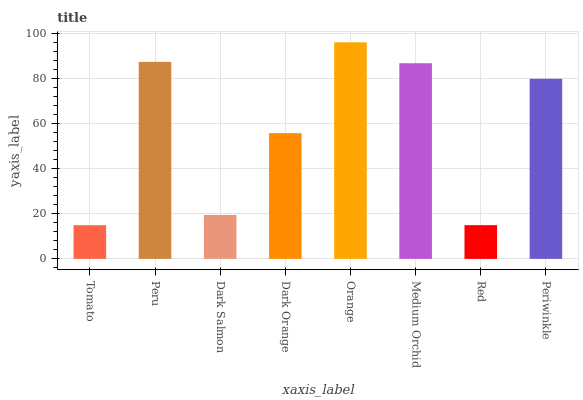Is Tomato the minimum?
Answer yes or no. Yes. Is Orange the maximum?
Answer yes or no. Yes. Is Peru the minimum?
Answer yes or no. No. Is Peru the maximum?
Answer yes or no. No. Is Peru greater than Tomato?
Answer yes or no. Yes. Is Tomato less than Peru?
Answer yes or no. Yes. Is Tomato greater than Peru?
Answer yes or no. No. Is Peru less than Tomato?
Answer yes or no. No. Is Periwinkle the high median?
Answer yes or no. Yes. Is Dark Orange the low median?
Answer yes or no. Yes. Is Peru the high median?
Answer yes or no. No. Is Medium Orchid the low median?
Answer yes or no. No. 